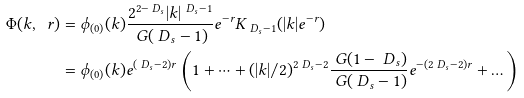Convert formula to latex. <formula><loc_0><loc_0><loc_500><loc_500>\Phi ( k , \ r ) & = \phi _ { ( 0 ) } ( k ) \frac { 2 ^ { 2 - \ D _ { s } } | k | ^ { \ D _ { s } - 1 } } { \ G ( \ D _ { s } - 1 ) } e ^ { - r } K _ { \ D _ { s } - 1 } ( | k | e ^ { - r } ) \\ & = \phi _ { ( 0 ) } ( k ) e ^ { ( \ D _ { s } - 2 ) r } \left ( 1 + \dots + ( | k | / 2 ) ^ { 2 \ D _ { s } - 2 } \frac { \ G ( 1 - \ D _ { s } ) } { \ G ( \ D _ { s } - 1 ) } e ^ { - ( 2 \ D _ { s } - 2 ) r } + \dots \right )</formula> 